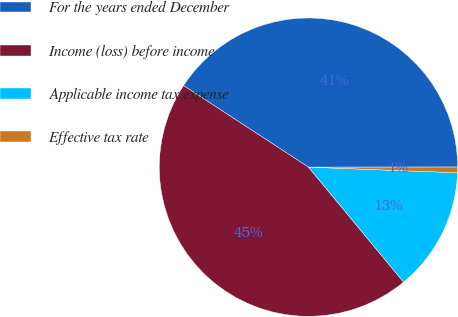Convert chart. <chart><loc_0><loc_0><loc_500><loc_500><pie_chart><fcel>For the years ended December<fcel>Income (loss) before income<fcel>Applicable income tax expense<fcel>Effective tax rate<nl><fcel>40.78%<fcel>45.21%<fcel>13.4%<fcel>0.61%<nl></chart> 